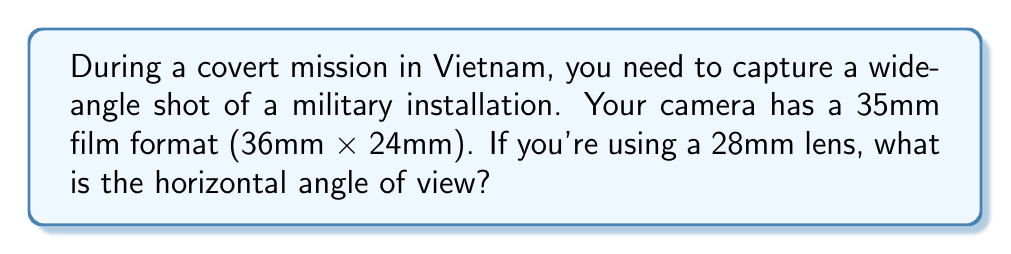Solve this math problem. To calculate the horizontal angle of view, we'll use the formula:

$$\text{Angle of View} = 2 \arctan\left(\frac{\text{Film Width}}{2f}\right)$$

Where $f$ is the focal length of the lens.

1. Film width (horizontal) = 36mm
2. Focal length = 28mm

Substituting these values into the formula:

$$\text{Angle of View} = 2 \arctan\left(\frac{36}{2 \cdot 28}\right)$$

$$= 2 \arctan\left(\frac{18}{28}\right)$$

$$= 2 \arctan(0.6428571429)$$

$$= 2 \cdot 32.73^\circ$$

$$= 65.46^\circ$$

Rounding to the nearest degree:

$$\text{Horizontal Angle of View} \approx 65^\circ$$
Answer: $65^\circ$ 